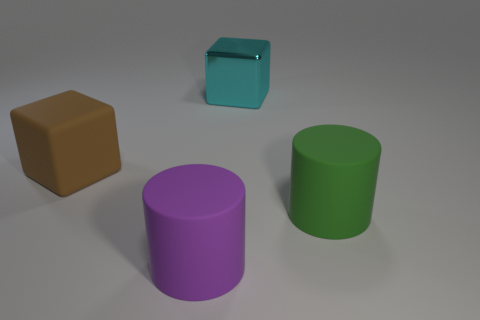Is there any other thing that is the same material as the cyan thing?
Keep it short and to the point. No. What is the material of the green thing that is the same shape as the large purple thing?
Provide a succinct answer. Rubber. Are there any small green cubes?
Provide a short and direct response. No. There is a large brown thing that is the same material as the purple object; what shape is it?
Your response must be concise. Cube. There is a large block that is in front of the metal cube; what material is it?
Your response must be concise. Rubber. Do the thing behind the big rubber cube and the matte cube have the same color?
Your response must be concise. No. How big is the rubber cylinder left of the large cylinder to the right of the big metallic cube?
Your answer should be very brief. Large. Is the number of brown matte objects that are on the right side of the cyan metallic cube greater than the number of large cyan metallic objects?
Your answer should be compact. No. There is a brown rubber block behind the green matte cylinder; is it the same size as the large green matte object?
Provide a succinct answer. Yes. There is a big object that is both left of the green rubber object and to the right of the purple cylinder; what is its color?
Your answer should be compact. Cyan. 